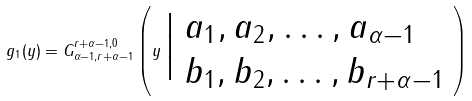<formula> <loc_0><loc_0><loc_500><loc_500>g _ { 1 } ( y ) = G ^ { r + \alpha - 1 , 0 } _ { \alpha - 1 , r + \alpha - 1 } \left ( y \, \Big | \begin{array} { l } a _ { 1 } , a _ { 2 } , \dots , a _ { \alpha - 1 } \\ b _ { 1 } , b _ { 2 } , \dots , b _ { r + \alpha - 1 } \end{array} \right )</formula> 